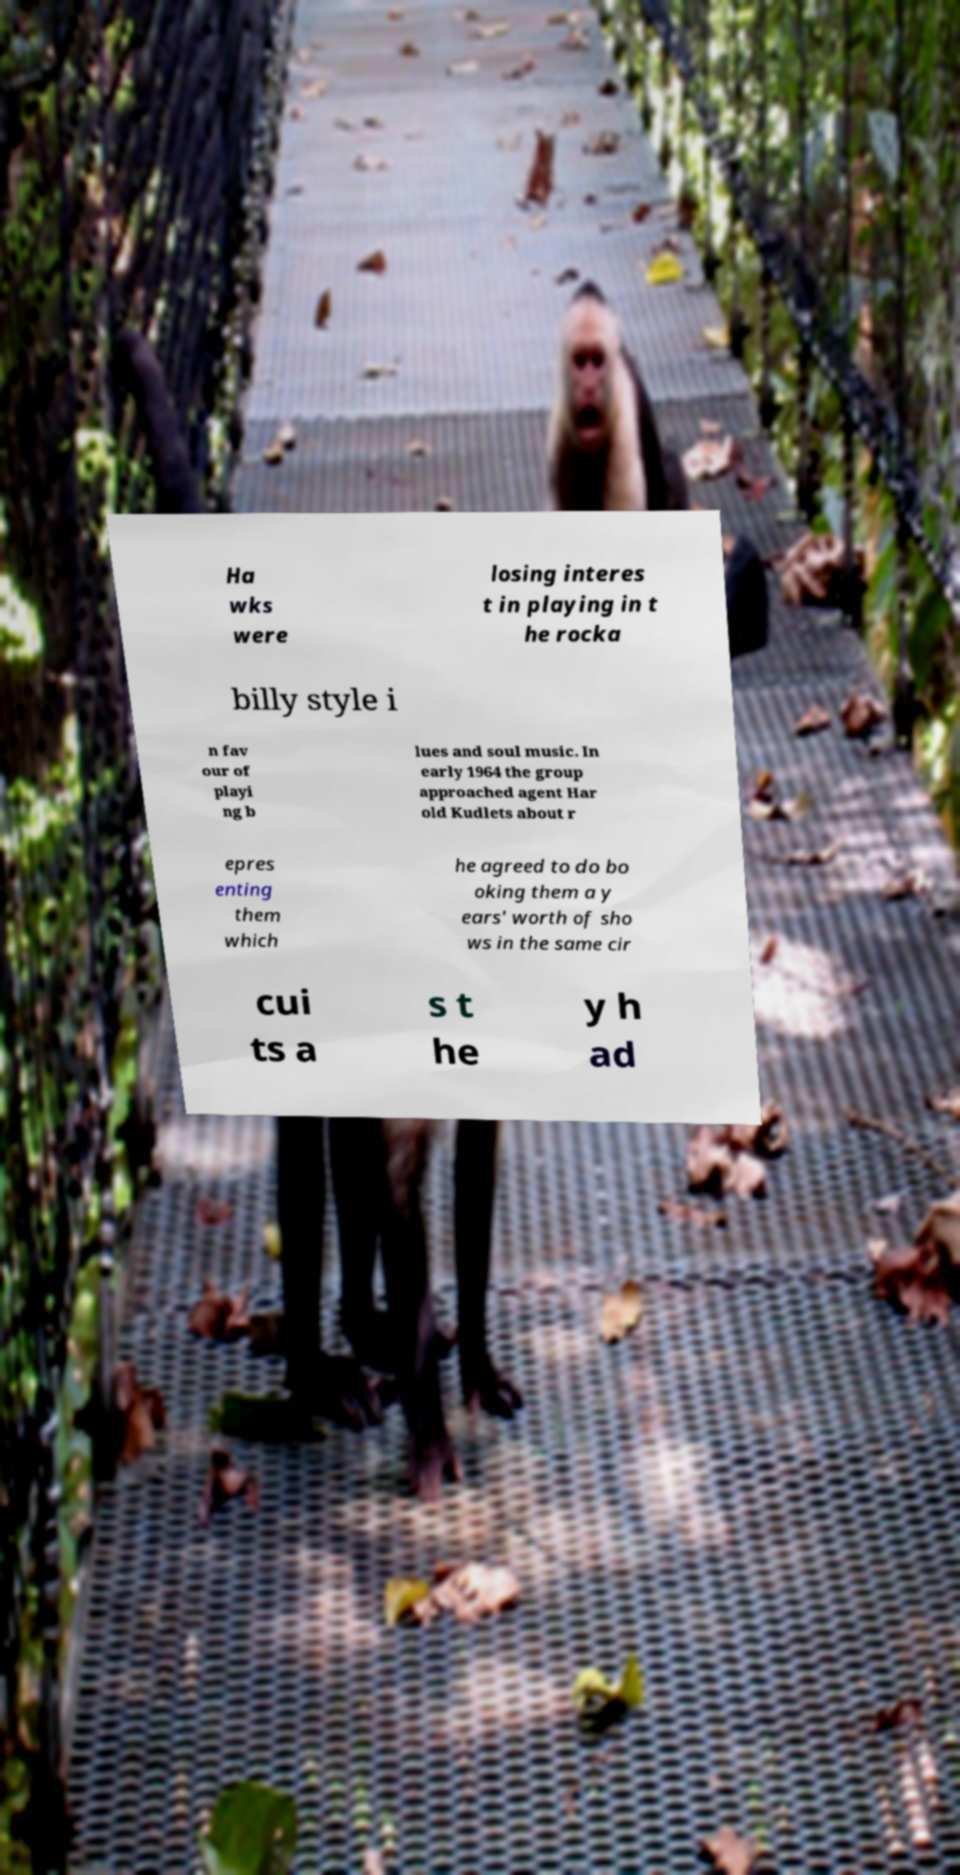There's text embedded in this image that I need extracted. Can you transcribe it verbatim? Ha wks were losing interes t in playing in t he rocka billy style i n fav our of playi ng b lues and soul music. In early 1964 the group approached agent Har old Kudlets about r epres enting them which he agreed to do bo oking them a y ears' worth of sho ws in the same cir cui ts a s t he y h ad 